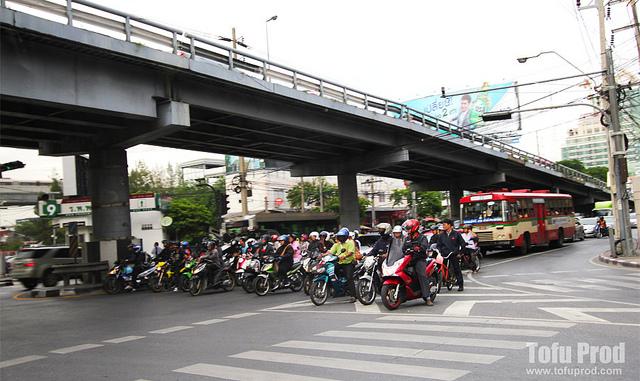What color is the bus?
Short answer required. Red. Is this a busy street?
Concise answer only. Yes. How many motorcycles are there?
Concise answer only. 30. 